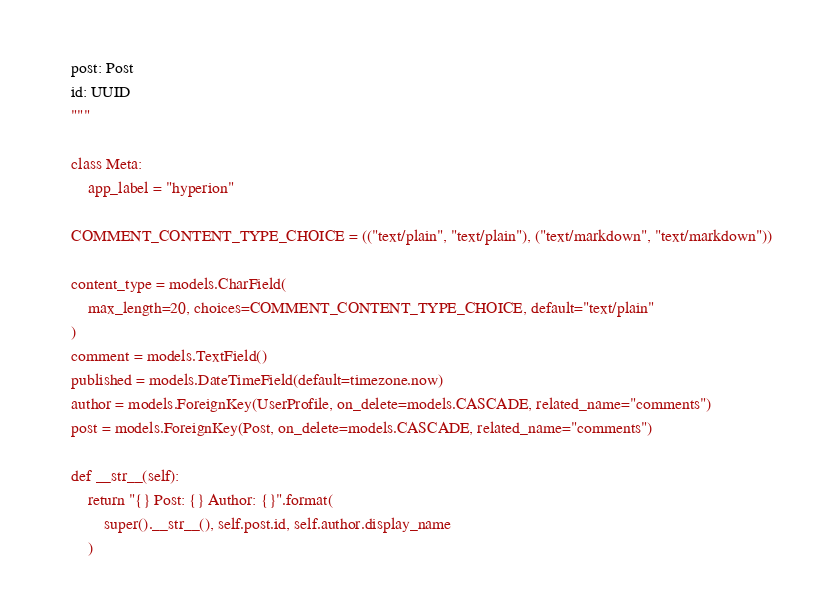Convert code to text. <code><loc_0><loc_0><loc_500><loc_500><_Python_>    post: Post
    id: UUID
    """

    class Meta:
        app_label = "hyperion"

    COMMENT_CONTENT_TYPE_CHOICE = (("text/plain", "text/plain"), ("text/markdown", "text/markdown"))

    content_type = models.CharField(
        max_length=20, choices=COMMENT_CONTENT_TYPE_CHOICE, default="text/plain"
    )
    comment = models.TextField()
    published = models.DateTimeField(default=timezone.now)
    author = models.ForeignKey(UserProfile, on_delete=models.CASCADE, related_name="comments")
    post = models.ForeignKey(Post, on_delete=models.CASCADE, related_name="comments")

    def __str__(self):
        return "{} Post: {} Author: {}".format(
            super().__str__(), self.post.id, self.author.display_name
        )
</code> 